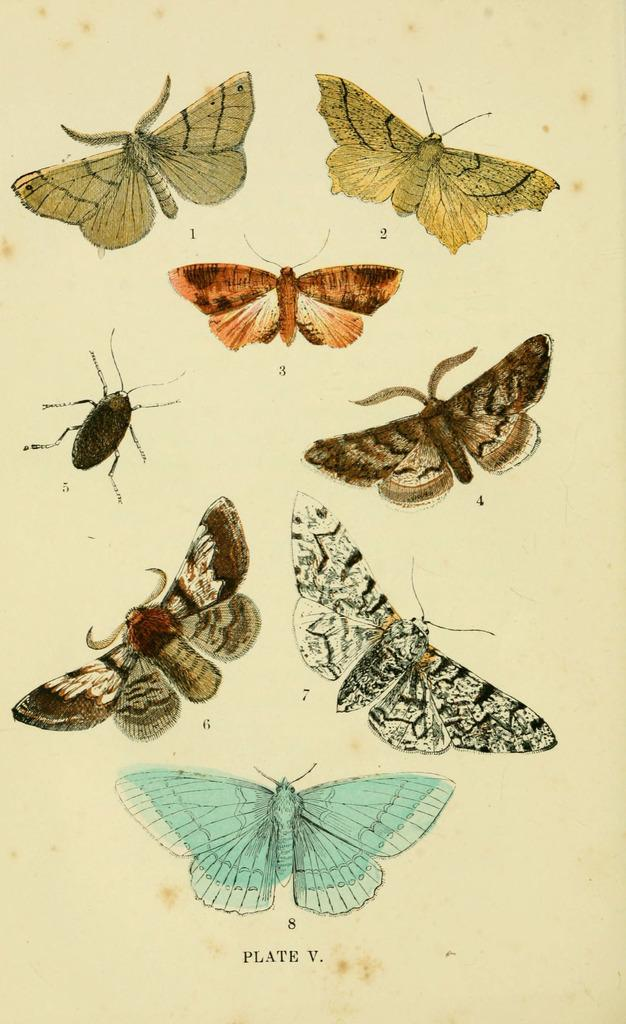What type of images can be seen on the paper in the image? There are butterfly and insect images on the paper. What else is present on the paper besides the images? There is text visible on the paper. What type of bread is being used to make the oatmeal in the image? There is no bread or oatmeal present in the image; it only features butterfly and insect images on a paper with accompanying text. 